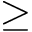Convert formula to latex. <formula><loc_0><loc_0><loc_500><loc_500>\geq</formula> 